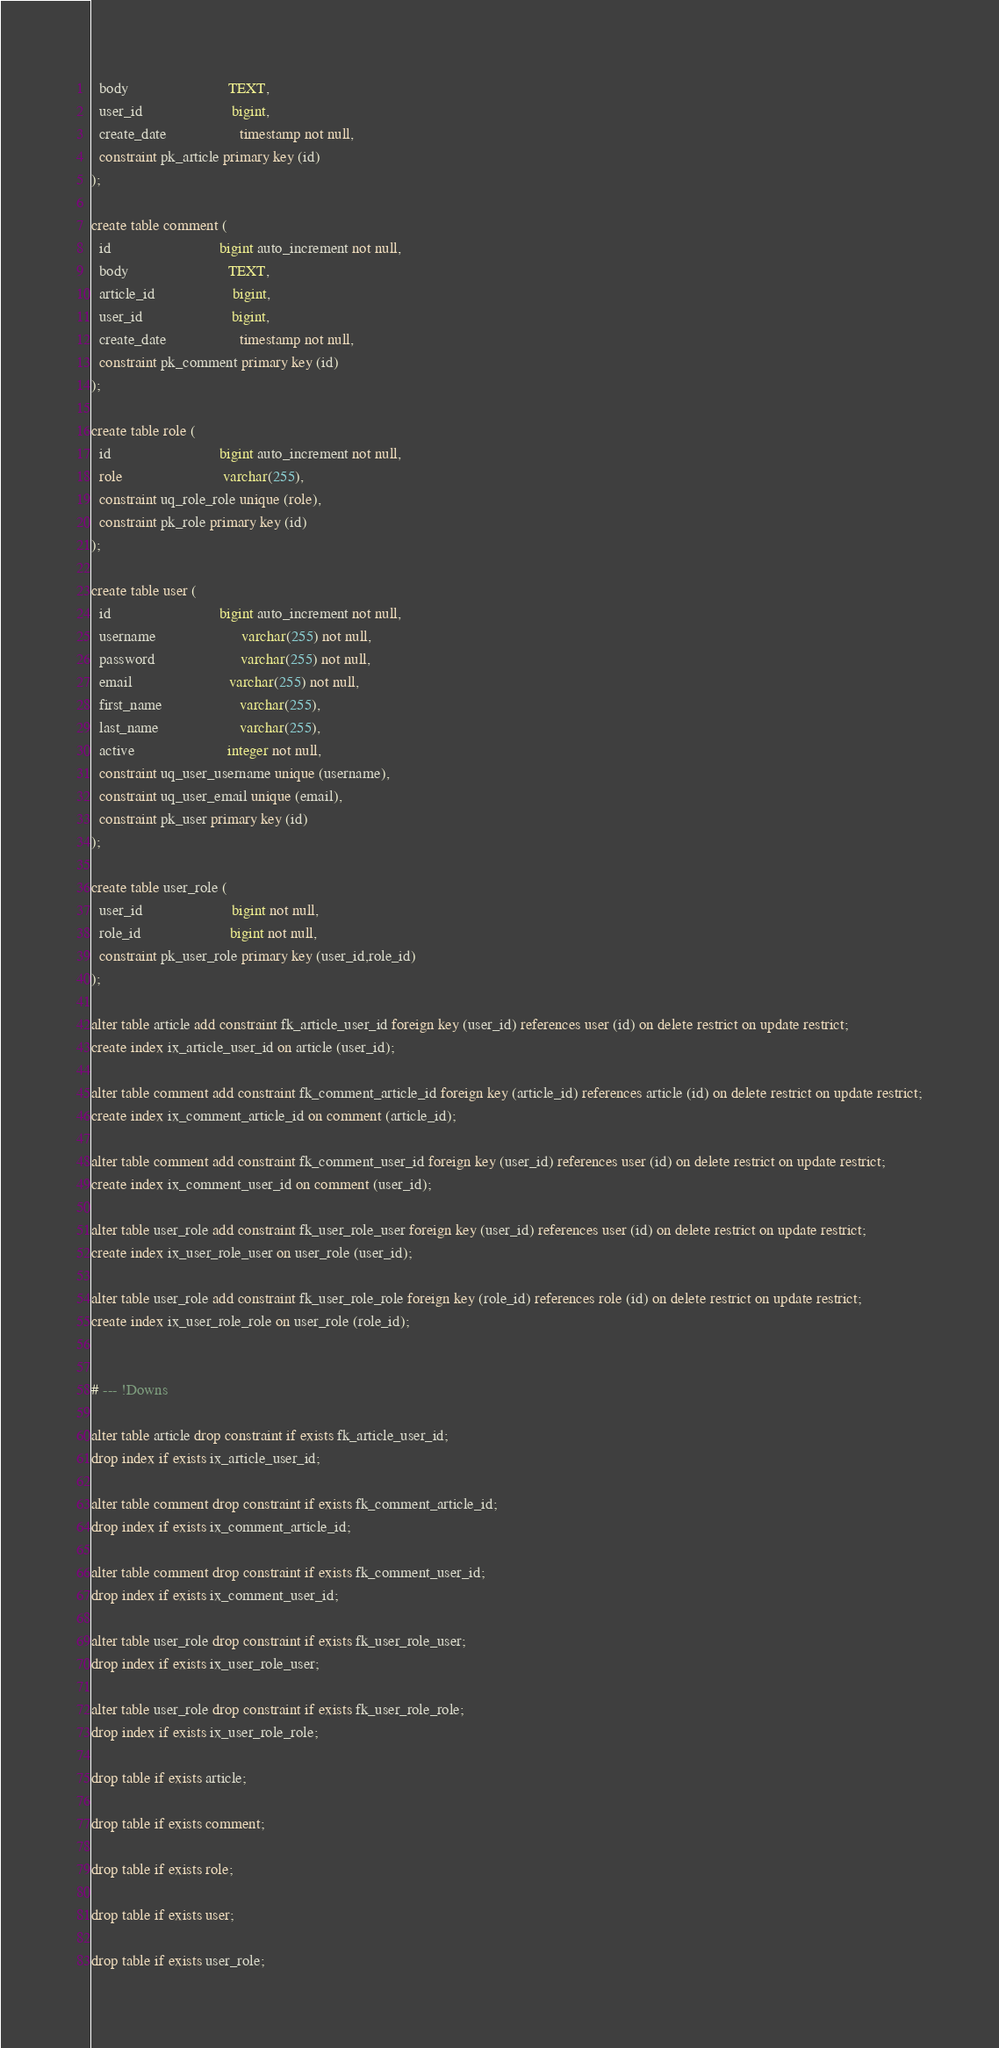<code> <loc_0><loc_0><loc_500><loc_500><_SQL_>  body                          TEXT,
  user_id                       bigint,
  create_date                   timestamp not null,
  constraint pk_article primary key (id)
);

create table comment (
  id                            bigint auto_increment not null,
  body                          TEXT,
  article_id                    bigint,
  user_id                       bigint,
  create_date                   timestamp not null,
  constraint pk_comment primary key (id)
);

create table role (
  id                            bigint auto_increment not null,
  role                          varchar(255),
  constraint uq_role_role unique (role),
  constraint pk_role primary key (id)
);

create table user (
  id                            bigint auto_increment not null,
  username                      varchar(255) not null,
  password                      varchar(255) not null,
  email                         varchar(255) not null,
  first_name                    varchar(255),
  last_name                     varchar(255),
  active                        integer not null,
  constraint uq_user_username unique (username),
  constraint uq_user_email unique (email),
  constraint pk_user primary key (id)
);

create table user_role (
  user_id                       bigint not null,
  role_id                       bigint not null,
  constraint pk_user_role primary key (user_id,role_id)
);

alter table article add constraint fk_article_user_id foreign key (user_id) references user (id) on delete restrict on update restrict;
create index ix_article_user_id on article (user_id);

alter table comment add constraint fk_comment_article_id foreign key (article_id) references article (id) on delete restrict on update restrict;
create index ix_comment_article_id on comment (article_id);

alter table comment add constraint fk_comment_user_id foreign key (user_id) references user (id) on delete restrict on update restrict;
create index ix_comment_user_id on comment (user_id);

alter table user_role add constraint fk_user_role_user foreign key (user_id) references user (id) on delete restrict on update restrict;
create index ix_user_role_user on user_role (user_id);

alter table user_role add constraint fk_user_role_role foreign key (role_id) references role (id) on delete restrict on update restrict;
create index ix_user_role_role on user_role (role_id);


# --- !Downs

alter table article drop constraint if exists fk_article_user_id;
drop index if exists ix_article_user_id;

alter table comment drop constraint if exists fk_comment_article_id;
drop index if exists ix_comment_article_id;

alter table comment drop constraint if exists fk_comment_user_id;
drop index if exists ix_comment_user_id;

alter table user_role drop constraint if exists fk_user_role_user;
drop index if exists ix_user_role_user;

alter table user_role drop constraint if exists fk_user_role_role;
drop index if exists ix_user_role_role;

drop table if exists article;

drop table if exists comment;

drop table if exists role;

drop table if exists user;

drop table if exists user_role;

</code> 